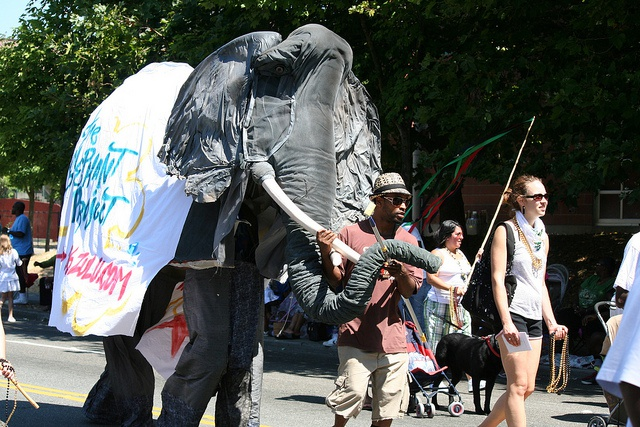Describe the objects in this image and their specific colors. I can see people in lightblue, black, ivory, lightpink, and gray tones, people in lightblue, white, black, gray, and tan tones, people in lightblue, white, darkgray, gray, and black tones, dog in lightblue, black, gray, maroon, and darkgray tones, and people in lightblue, black, teal, and darkgreen tones in this image. 